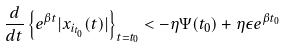Convert formula to latex. <formula><loc_0><loc_0><loc_500><loc_500>\frac { d } { d t } \left \{ e ^ { \beta t } | x _ { i _ { t _ { 0 } } } ( t ) | \right \} _ { t = t _ { 0 } } < - \eta \Psi ( t _ { 0 } ) + \eta \epsilon e ^ { \beta t _ { 0 } }</formula> 